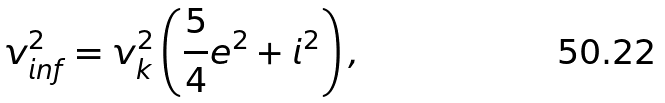Convert formula to latex. <formula><loc_0><loc_0><loc_500><loc_500>v _ { i n f } ^ { 2 } = v _ { k } ^ { 2 } \left ( \frac { 5 } { 4 } e ^ { 2 } + i ^ { 2 } \right ) ,</formula> 